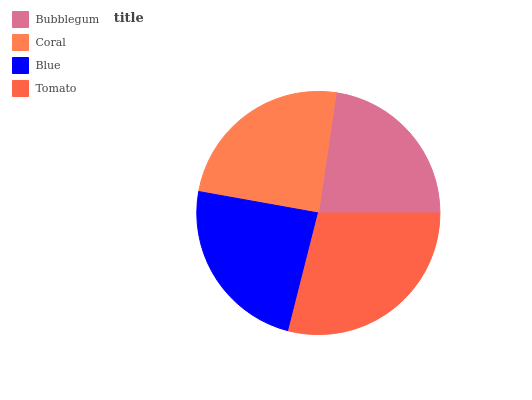Is Bubblegum the minimum?
Answer yes or no. Yes. Is Tomato the maximum?
Answer yes or no. Yes. Is Coral the minimum?
Answer yes or no. No. Is Coral the maximum?
Answer yes or no. No. Is Coral greater than Bubblegum?
Answer yes or no. Yes. Is Bubblegum less than Coral?
Answer yes or no. Yes. Is Bubblegum greater than Coral?
Answer yes or no. No. Is Coral less than Bubblegum?
Answer yes or no. No. Is Coral the high median?
Answer yes or no. Yes. Is Blue the low median?
Answer yes or no. Yes. Is Blue the high median?
Answer yes or no. No. Is Bubblegum the low median?
Answer yes or no. No. 